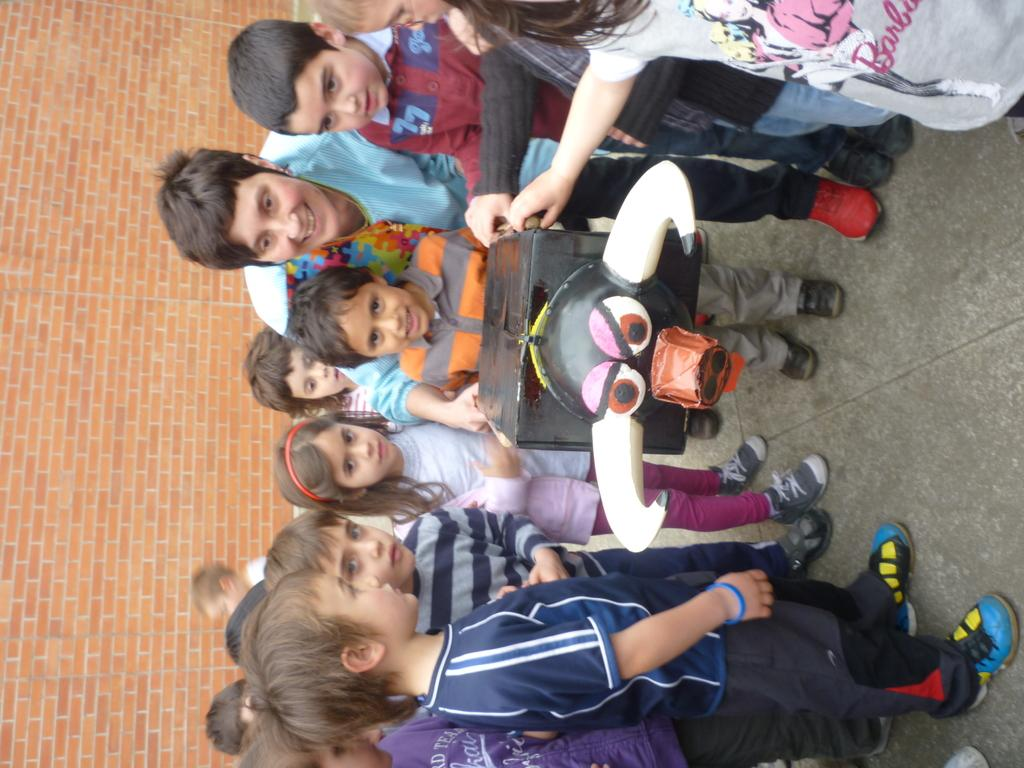What is the main subject of the image? The main subject of the image is a group of children. Where are the children located in the image? The children are standing on the road in the image. What are the children holding in the image? The children are holding a box in the image. What can be seen in the background of the image? There is a wall in the background of the image. What type of hook is the children using to play with the ball in the image? There is no hook or ball present in the image; the children are holding a box. 